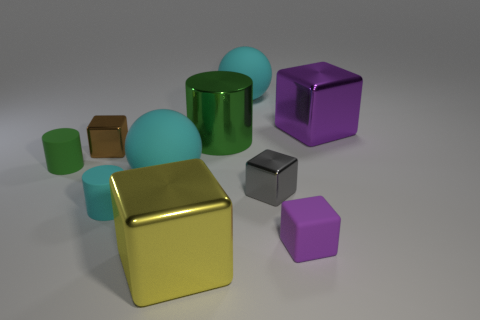There is a cyan matte thing that is the same size as the purple rubber cube; what is its shape?
Make the answer very short. Cylinder. There is a sphere that is behind the large green metallic cylinder; are there any big purple blocks that are in front of it?
Keep it short and to the point. Yes. What color is the other tiny metal object that is the same shape as the tiny gray metal object?
Your answer should be compact. Brown. There is a cube that is behind the green shiny cylinder; is it the same color as the small matte block?
Provide a succinct answer. Yes. How many things are metallic things on the right side of the green metal object or tiny purple matte objects?
Offer a very short reply. 3. There is a small object that is left of the cube to the left of the cyan sphere that is in front of the brown object; what is its material?
Keep it short and to the point. Rubber. Are there more metal cubes left of the purple rubber object than shiny cubes that are on the right side of the big yellow metallic cube?
Your answer should be compact. Yes. What number of cylinders are large things or tiny shiny things?
Provide a short and direct response. 1. How many gray things are on the left side of the large shiny cube that is behind the big metal object in front of the brown metallic object?
Give a very brief answer. 1. There is a thing that is the same color as the metallic cylinder; what material is it?
Make the answer very short. Rubber. 